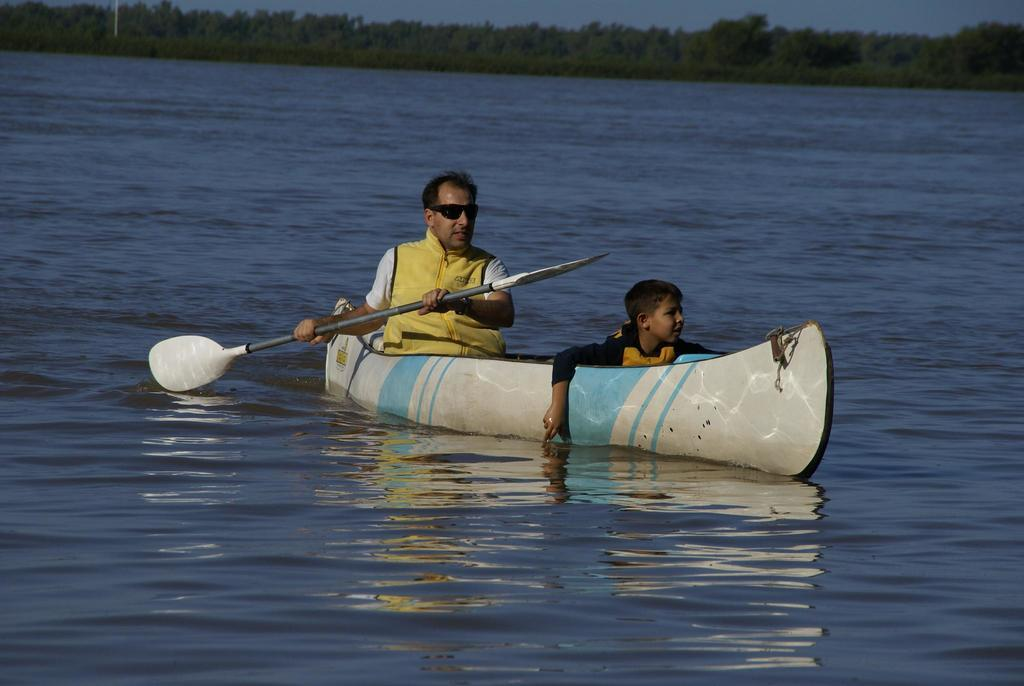Who is present in the image? There is a boy and a man in the image. What are they holding in the image? They are holding a paddle in the image. Where are they sitting in the image? They are sitting on a boat in the image. What is the boat's location in the image? The boat is on the water in the image. What can be seen in the background of the image? There are trees and the sky visible in the background of the image. What type of leather is used to make the sign in the image? There is no sign present in the image, so it is not possible to determine what type of leather might be used. 